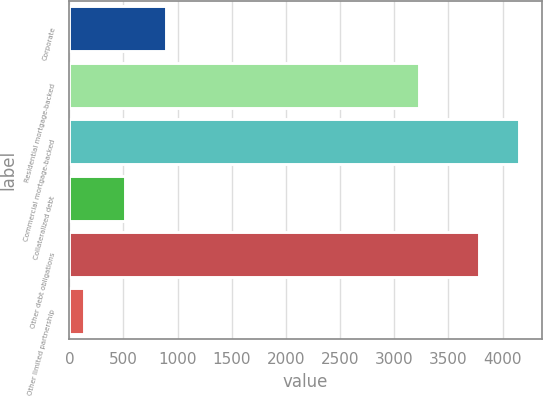Convert chart to OTSL. <chart><loc_0><loc_0><loc_500><loc_500><bar_chart><fcel>Corporate<fcel>Residential mortgage-backed<fcel>Commercial mortgage-backed<fcel>Collateralized debt<fcel>Other debt obligations<fcel>Other limited partnership<nl><fcel>888.44<fcel>3226.7<fcel>4155.32<fcel>512.32<fcel>3779.2<fcel>136.2<nl></chart> 